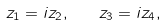<formula> <loc_0><loc_0><loc_500><loc_500>z _ { 1 } = i z _ { 2 } , \quad z _ { 3 } = i z _ { 4 } ,</formula> 